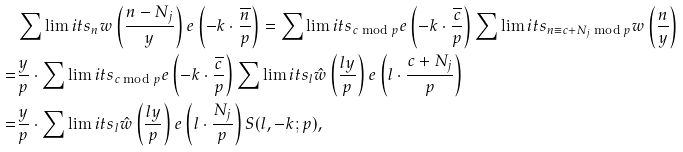Convert formula to latex. <formula><loc_0><loc_0><loc_500><loc_500>& \sum \lim i t s _ { n } w \left ( \frac { n - N _ { j } } { y } \right ) e \left ( - k \cdot \frac { \overline { n } } { p } \right ) = \sum \lim i t s _ { c \bmod { p } } e \left ( - k \cdot \frac { \overline { c } } { p } \right ) \sum \lim i t s _ { n \equiv c + N _ { j } \bmod { p } } w \left ( \frac { n } { y } \right ) \\ = & \frac { y } { p } \cdot \sum \lim i t s _ { c \bmod { p } } e \left ( - k \cdot \frac { \overline { c } } { p } \right ) \sum \lim i t s _ { l } \hat { w } \left ( \frac { l y } { p } \right ) e \left ( l \cdot \frac { c + N _ { j } } { p } \right ) \\ = & \frac { y } { p } \cdot \sum \lim i t s _ { l } \hat { w } \left ( \frac { l y } { p } \right ) e \left ( l \cdot \frac { N _ { j } } { p } \right ) S ( l , - k ; p ) ,</formula> 